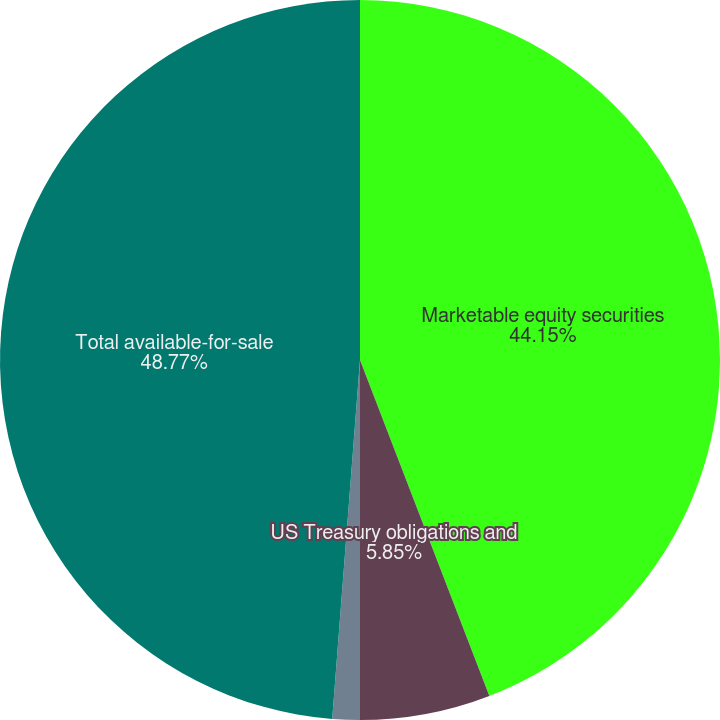Convert chart to OTSL. <chart><loc_0><loc_0><loc_500><loc_500><pie_chart><fcel>Marketable equity securities<fcel>US Treasury obligations and<fcel>Other debt securities<fcel>Total available-for-sale<nl><fcel>44.15%<fcel>5.85%<fcel>1.23%<fcel>48.77%<nl></chart> 